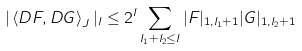Convert formula to latex. <formula><loc_0><loc_0><loc_500><loc_500>| \left \langle D F , D G \right \rangle _ { J } | _ { l } \leq 2 ^ { l } \sum _ { l _ { 1 } + l _ { 2 } \leq l } | F | _ { 1 , l _ { 1 } + 1 } | G | _ { 1 , l _ { 2 } + 1 }</formula> 